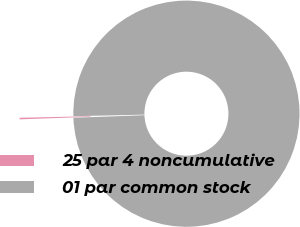<chart> <loc_0><loc_0><loc_500><loc_500><pie_chart><fcel>25 par 4 noncumulative<fcel>01 par common stock<nl><fcel>0.22%<fcel>99.78%<nl></chart> 